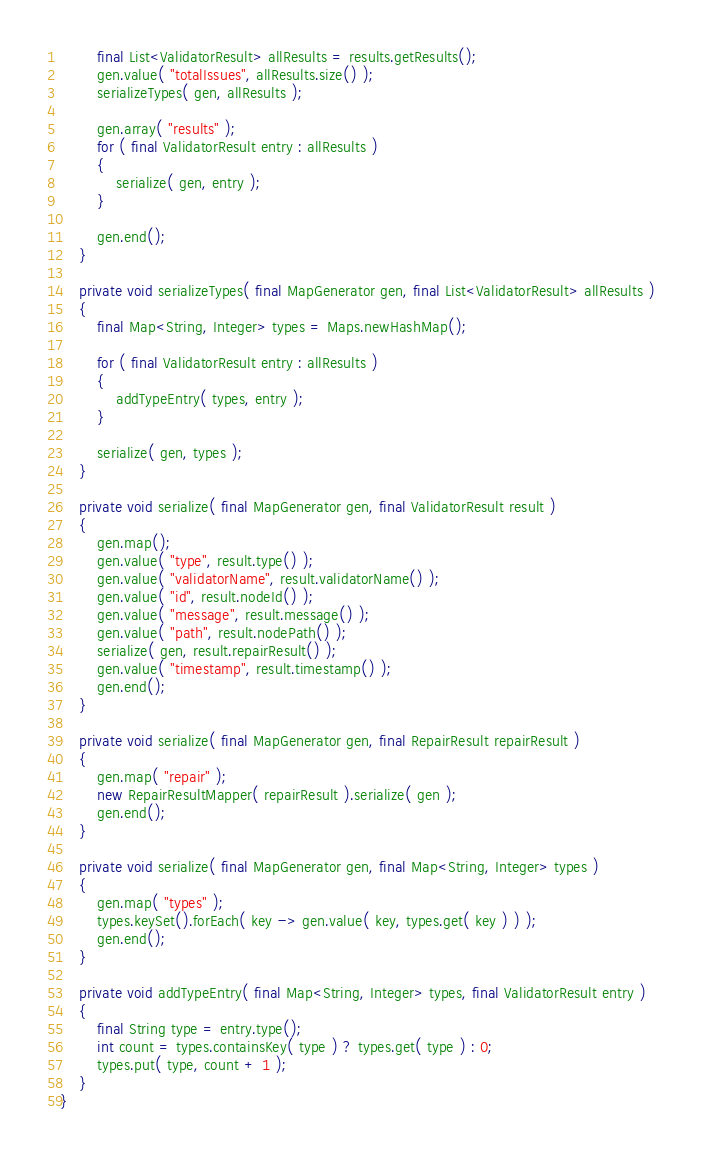Convert code to text. <code><loc_0><loc_0><loc_500><loc_500><_Java_>        final List<ValidatorResult> allResults = results.getResults();
        gen.value( "totalIssues", allResults.size() );
        serializeTypes( gen, allResults );

        gen.array( "results" );
        for ( final ValidatorResult entry : allResults )
        {
            serialize( gen, entry );
        }

        gen.end();
    }

    private void serializeTypes( final MapGenerator gen, final List<ValidatorResult> allResults )
    {
        final Map<String, Integer> types = Maps.newHashMap();

        for ( final ValidatorResult entry : allResults )
        {
            addTypeEntry( types, entry );
        }

        serialize( gen, types );
    }

    private void serialize( final MapGenerator gen, final ValidatorResult result )
    {
        gen.map();
        gen.value( "type", result.type() );
        gen.value( "validatorName", result.validatorName() );
        gen.value( "id", result.nodeId() );
        gen.value( "message", result.message() );
        gen.value( "path", result.nodePath() );
        serialize( gen, result.repairResult() );
        gen.value( "timestamp", result.timestamp() );
        gen.end();
    }

    private void serialize( final MapGenerator gen, final RepairResult repairResult )
    {
        gen.map( "repair" );
        new RepairResultMapper( repairResult ).serialize( gen );
        gen.end();
    }

    private void serialize( final MapGenerator gen, final Map<String, Integer> types )
    {
        gen.map( "types" );
        types.keySet().forEach( key -> gen.value( key, types.get( key ) ) );
        gen.end();
    }

    private void addTypeEntry( final Map<String, Integer> types, final ValidatorResult entry )
    {
        final String type = entry.type();
        int count = types.containsKey( type ) ? types.get( type ) : 0;
        types.put( type, count + 1 );
    }
}
</code> 